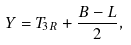Convert formula to latex. <formula><loc_0><loc_0><loc_500><loc_500>Y = T _ { 3 R } + \frac { B - L } { 2 } ,</formula> 